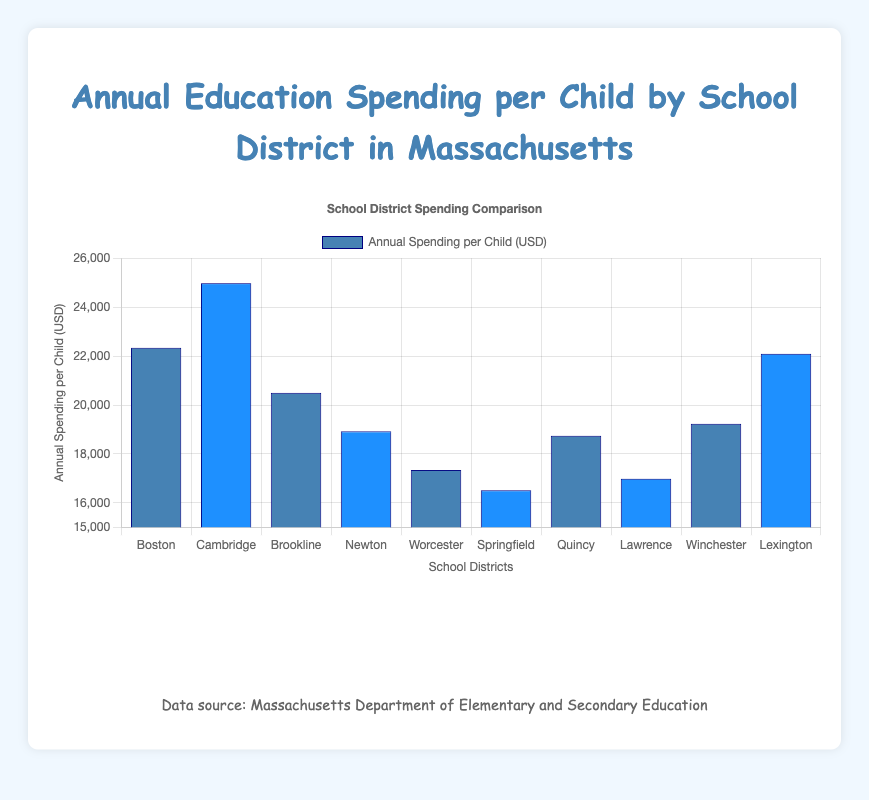What's the highest annual spending per child among the school districts? Look at the heights of the bars in the chart. The highest bar represents Cambridge Public Schools, where the annual spending per child is $24,987.
Answer: $24,987 Which school district has the lowest annual spending per child? Look for the shortest bar in the chart. The Springfield Public Schools has the lowest annual spending per child at $16,512.
Answer: $16,512 How much more does Cambridge Public Schools spend per child compared to Springfield Public Schools? Subtract the annual spending per child in Springfield ($16,512) from the spending in Cambridge ($24,987). The difference is $8,475.
Answer: $8,475 What's the average annual spending per child across all the school districts? Sum all the spending values and divide by the number of districts: (22345 + 24987 + 20499 + 18923 + 17345 + 16512 + 18745 + 16987 + 19234 + 22098) / 10 = $19,367.5
Answer: $19,367.5 Which two school districts have spending amounts closest to each other? Compare all pairs: the closest are Lawrence and Springfield with $16,987 and $16,512 respectively, difference of $475.
Answer: Lawrence and Springfield Compare the spending per child between Newton and Quincy Public Schools. Which spends more and by how much? Newton spends $18,923, while Quincy spends $18,745. Newton spends $178 more per child.
Answer: Newton by $178 What are the three school districts with the highest spending per child? Find the three tallest bars: Cambridge ($24,987), Boston ($22,345), and Lexington ($22,098).
Answer: Cambridge, Boston, Lexington Find the difference in spending per child between Boston Public Schools and Worcester Public Schools. Subtract the spending of Worcester ($17,345) from Boston ($22,345). The difference is $5,000.
Answer: $5,000 Which school district spends less: Winchester or Newton? By how much? Winchester spends $19,234, while Newton spends $18,923. Newton spends $311 less than Winchester.
Answer: Newton by $311 What's the median annual spending per child, and how did you calculate it? Arrange the spending amounts in ascending order and find the middle value. For 10 values, the median is the average of the 5th and 6th values: ($18,923 + $19,234) / 2 = $19,078.5
Answer: $19,078.5 